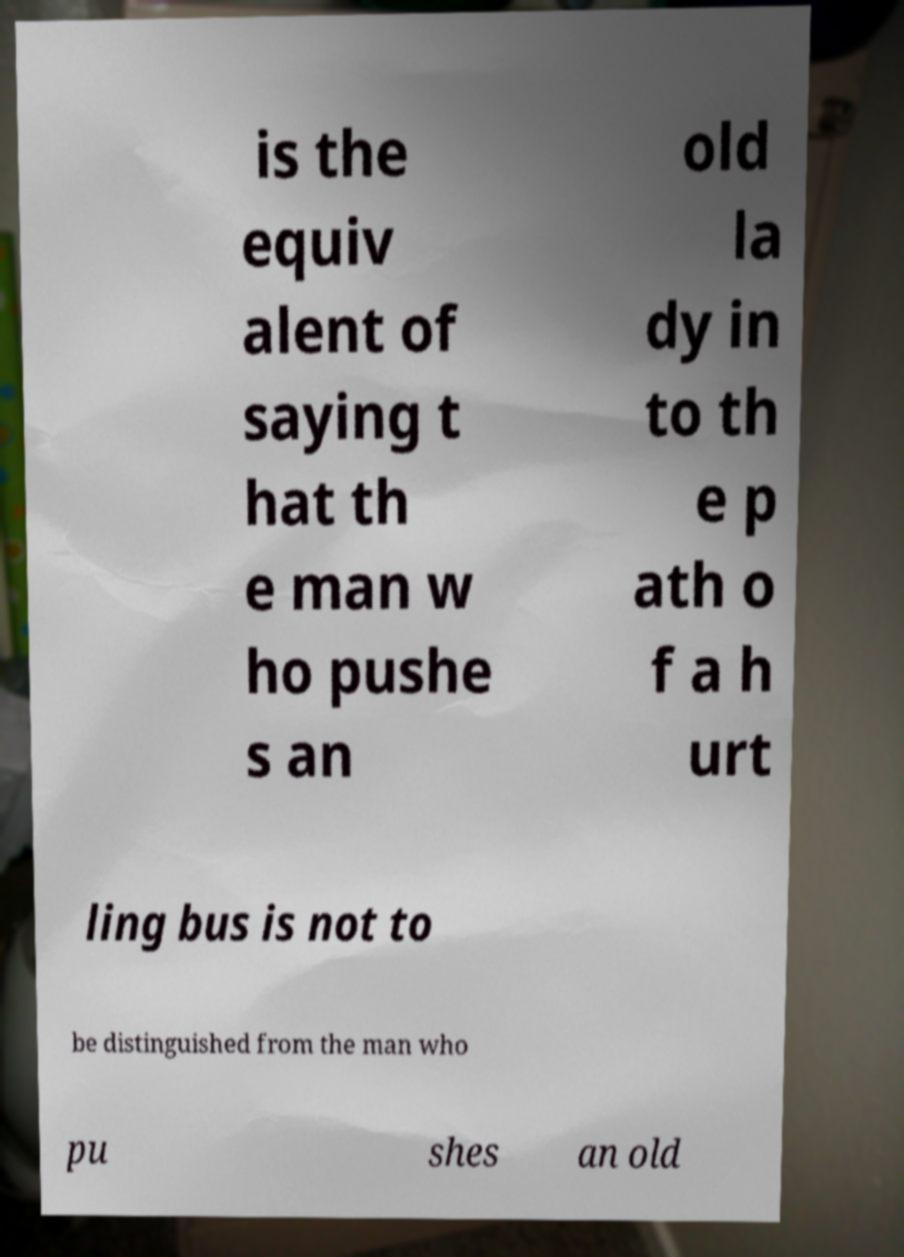Please identify and transcribe the text found in this image. is the equiv alent of saying t hat th e man w ho pushe s an old la dy in to th e p ath o f a h urt ling bus is not to be distinguished from the man who pu shes an old 